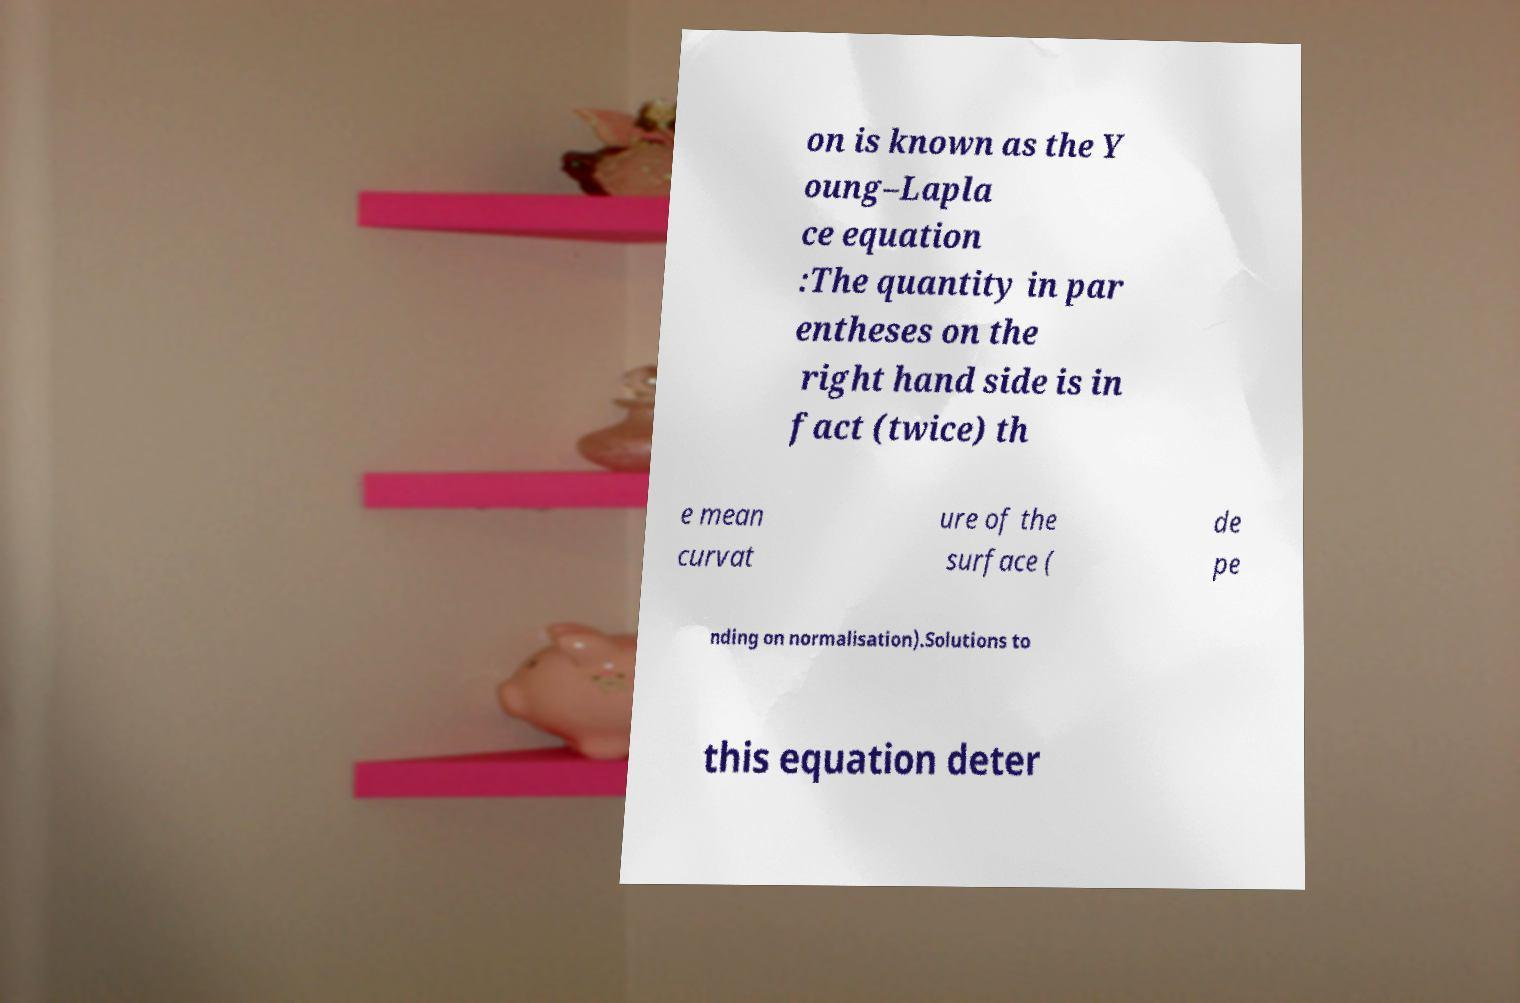Could you extract and type out the text from this image? on is known as the Y oung–Lapla ce equation :The quantity in par entheses on the right hand side is in fact (twice) th e mean curvat ure of the surface ( de pe nding on normalisation).Solutions to this equation deter 